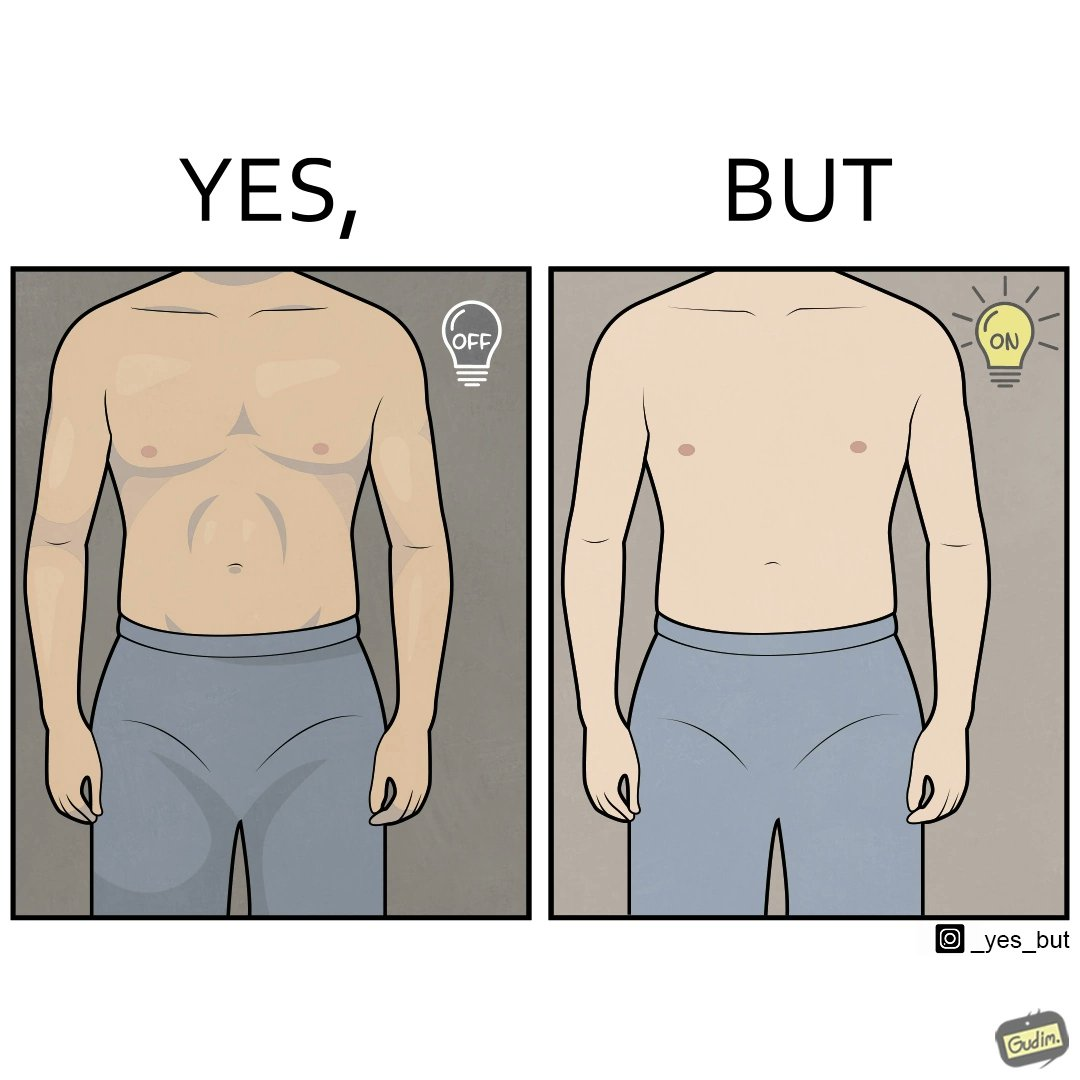Describe the contrast between the left and right parts of this image. In the left part of the image: It shows a muscular male body with a turned off bulb In the right part of the image: It shows a non athletic male body with a turned on bulb 